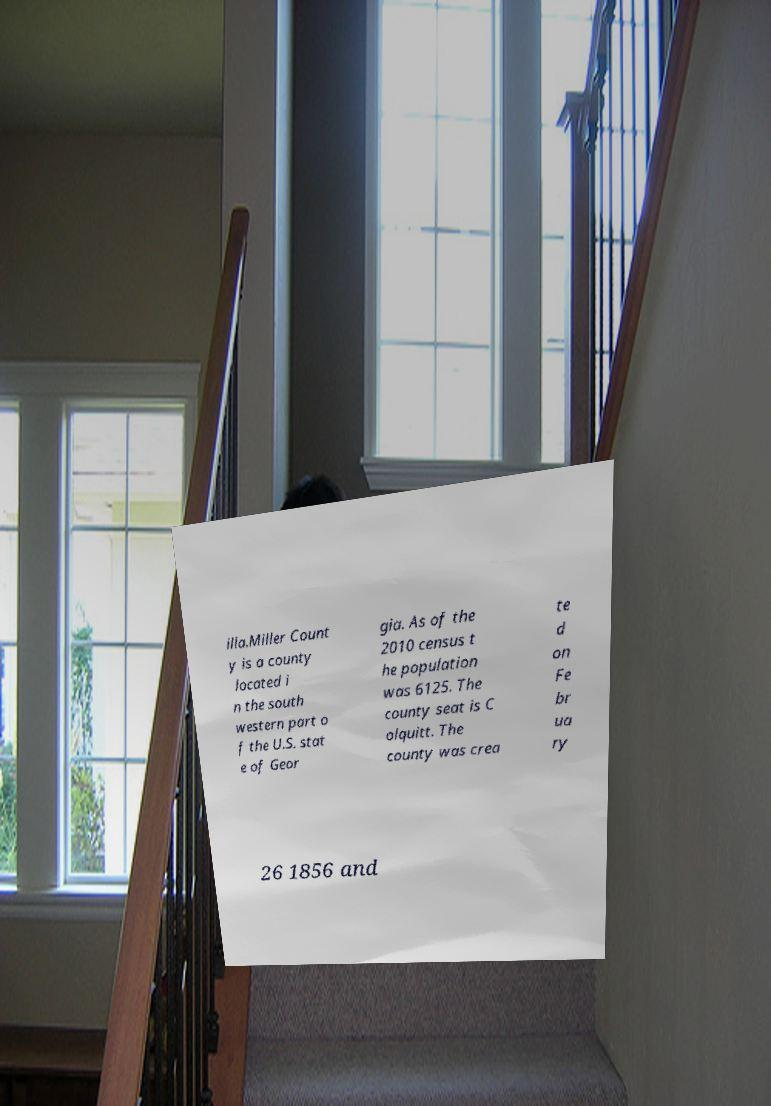There's text embedded in this image that I need extracted. Can you transcribe it verbatim? illa.Miller Count y is a county located i n the south western part o f the U.S. stat e of Geor gia. As of the 2010 census t he population was 6125. The county seat is C olquitt. The county was crea te d on Fe br ua ry 26 1856 and 